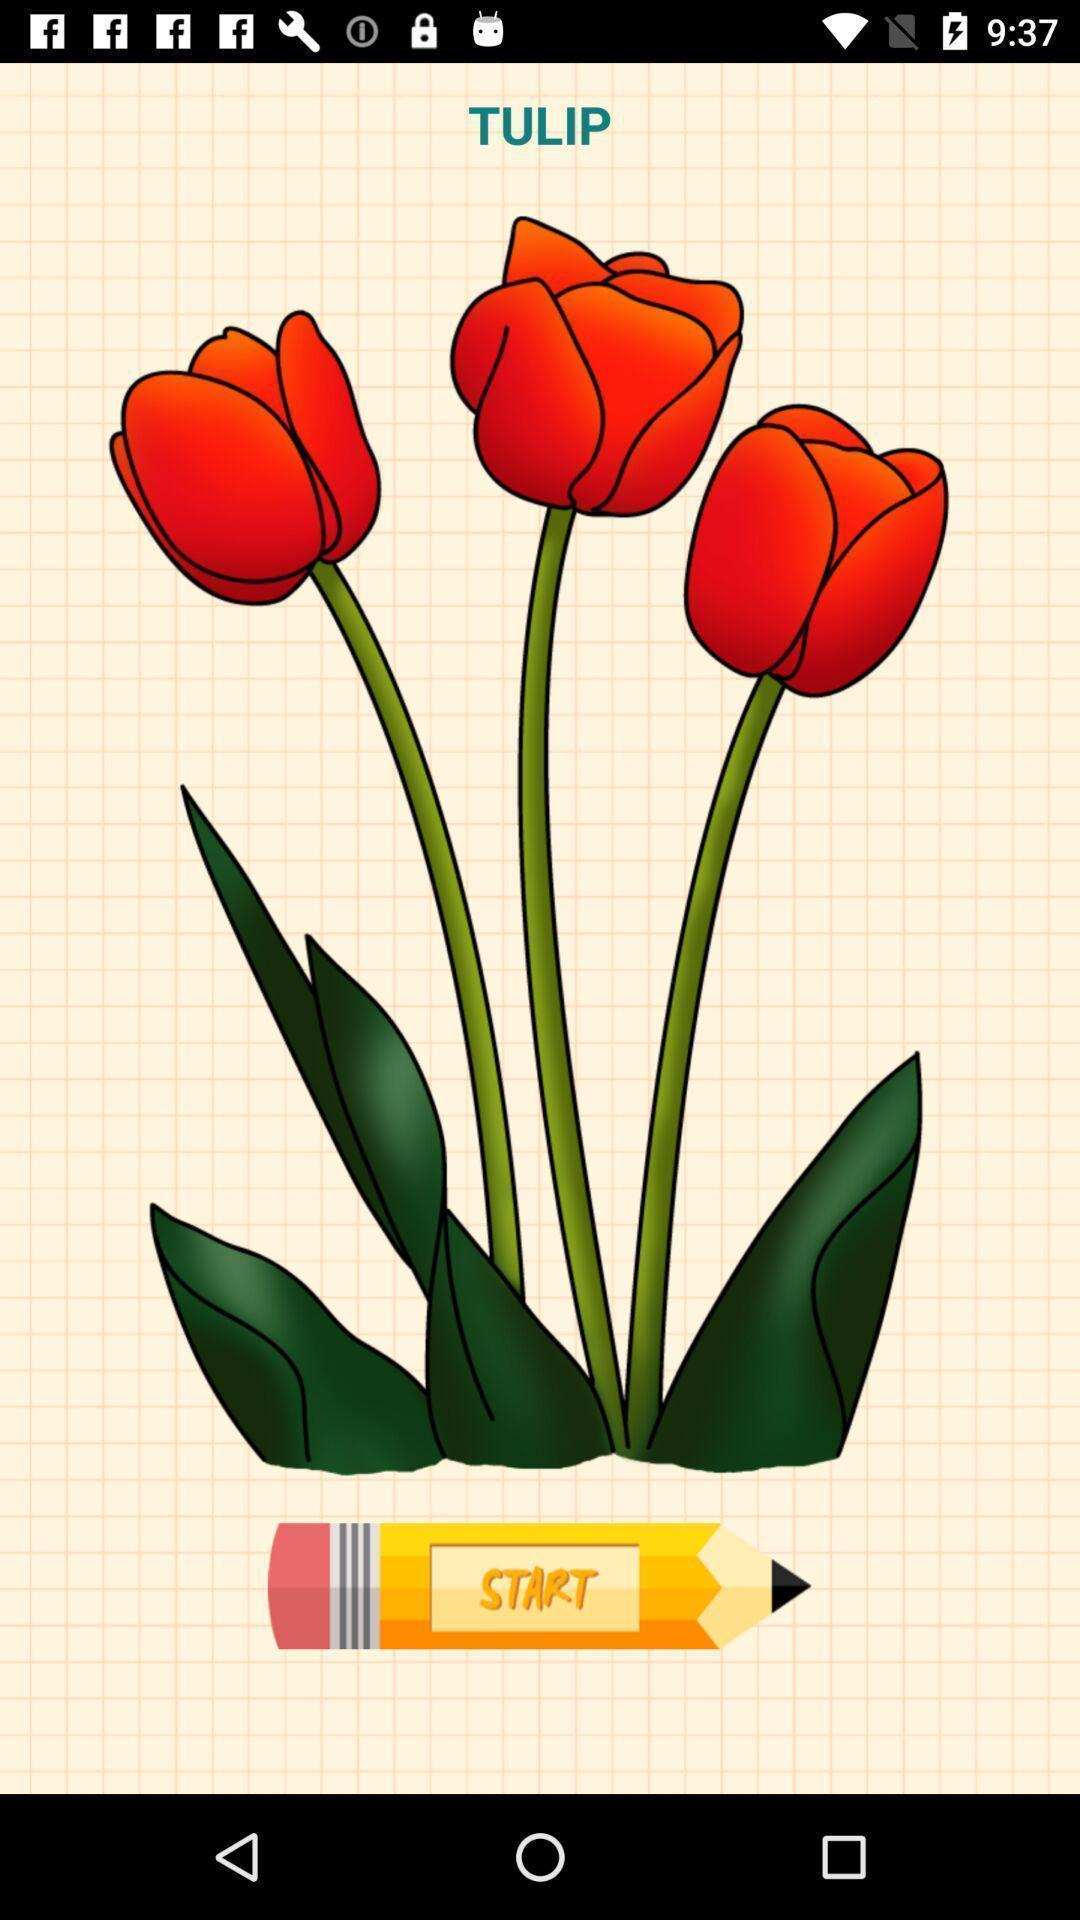Provide a detailed account of this screenshot. Window displaying a page for drawing. 